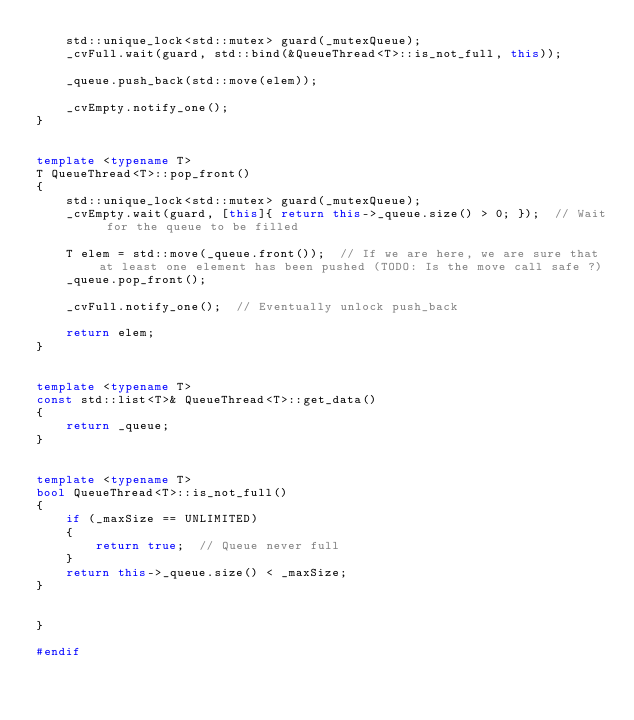Convert code to text. <code><loc_0><loc_0><loc_500><loc_500><_C++_>    std::unique_lock<std::mutex> guard(_mutexQueue);
    _cvFull.wait(guard, std::bind(&QueueThread<T>::is_not_full, this));

    _queue.push_back(std::move(elem));

    _cvEmpty.notify_one();
}


template <typename T>
T QueueThread<T>::pop_front()
{
    std::unique_lock<std::mutex> guard(_mutexQueue);
    _cvEmpty.wait(guard, [this]{ return this->_queue.size() > 0; });  // Wait for the queue to be filled

    T elem = std::move(_queue.front());  // If we are here, we are sure that at least one element has been pushed (TODO: Is the move call safe ?)
    _queue.pop_front();

    _cvFull.notify_one();  // Eventually unlock push_back

    return elem;
}


template <typename T>
const std::list<T>& QueueThread<T>::get_data()
{
    return _queue;
}


template <typename T>
bool QueueThread<T>::is_not_full()
{
    if (_maxSize == UNLIMITED)
    {
        return true;  // Queue never full
    }
    return this->_queue.size() < _maxSize;
}


}

#endif
</code> 